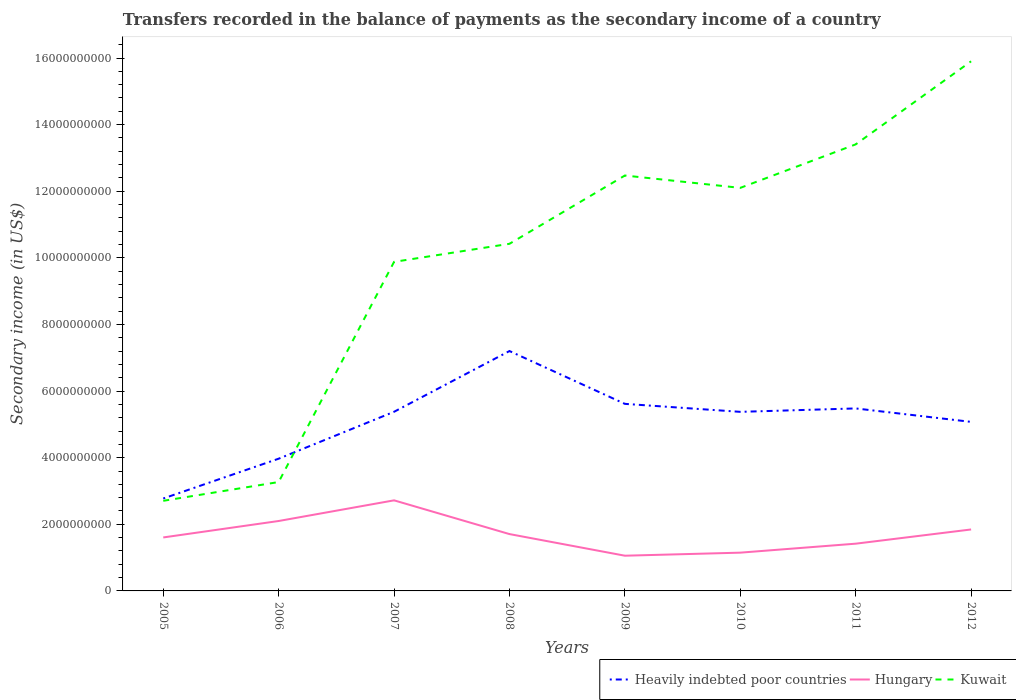Is the number of lines equal to the number of legend labels?
Make the answer very short. Yes. Across all years, what is the maximum secondary income of in Hungary?
Offer a very short reply. 1.06e+09. What is the total secondary income of in Hungary in the graph?
Your answer should be very brief. -1.39e+08. What is the difference between the highest and the second highest secondary income of in Kuwait?
Offer a very short reply. 1.32e+1. Is the secondary income of in Heavily indebted poor countries strictly greater than the secondary income of in Kuwait over the years?
Your response must be concise. No. Does the graph contain any zero values?
Your answer should be compact. No. How many legend labels are there?
Provide a succinct answer. 3. What is the title of the graph?
Your answer should be compact. Transfers recorded in the balance of payments as the secondary income of a country. What is the label or title of the Y-axis?
Give a very brief answer. Secondary income (in US$). What is the Secondary income (in US$) in Heavily indebted poor countries in 2005?
Make the answer very short. 2.77e+09. What is the Secondary income (in US$) of Hungary in 2005?
Make the answer very short. 1.61e+09. What is the Secondary income (in US$) in Kuwait in 2005?
Ensure brevity in your answer.  2.71e+09. What is the Secondary income (in US$) in Heavily indebted poor countries in 2006?
Offer a very short reply. 3.97e+09. What is the Secondary income (in US$) in Hungary in 2006?
Provide a short and direct response. 2.10e+09. What is the Secondary income (in US$) in Kuwait in 2006?
Ensure brevity in your answer.  3.27e+09. What is the Secondary income (in US$) in Heavily indebted poor countries in 2007?
Offer a very short reply. 5.38e+09. What is the Secondary income (in US$) in Hungary in 2007?
Give a very brief answer. 2.72e+09. What is the Secondary income (in US$) in Kuwait in 2007?
Offer a terse response. 9.88e+09. What is the Secondary income (in US$) in Heavily indebted poor countries in 2008?
Provide a succinct answer. 7.20e+09. What is the Secondary income (in US$) of Hungary in 2008?
Keep it short and to the point. 1.71e+09. What is the Secondary income (in US$) of Kuwait in 2008?
Your response must be concise. 1.04e+1. What is the Secondary income (in US$) in Heavily indebted poor countries in 2009?
Ensure brevity in your answer.  5.62e+09. What is the Secondary income (in US$) of Hungary in 2009?
Give a very brief answer. 1.06e+09. What is the Secondary income (in US$) of Kuwait in 2009?
Your response must be concise. 1.25e+1. What is the Secondary income (in US$) of Heavily indebted poor countries in 2010?
Give a very brief answer. 5.38e+09. What is the Secondary income (in US$) in Hungary in 2010?
Give a very brief answer. 1.15e+09. What is the Secondary income (in US$) in Kuwait in 2010?
Provide a short and direct response. 1.21e+1. What is the Secondary income (in US$) in Heavily indebted poor countries in 2011?
Provide a succinct answer. 5.48e+09. What is the Secondary income (in US$) of Hungary in 2011?
Provide a short and direct response. 1.42e+09. What is the Secondary income (in US$) of Kuwait in 2011?
Make the answer very short. 1.34e+1. What is the Secondary income (in US$) of Heavily indebted poor countries in 2012?
Your answer should be compact. 5.08e+09. What is the Secondary income (in US$) in Hungary in 2012?
Keep it short and to the point. 1.85e+09. What is the Secondary income (in US$) of Kuwait in 2012?
Provide a short and direct response. 1.59e+1. Across all years, what is the maximum Secondary income (in US$) of Heavily indebted poor countries?
Your response must be concise. 7.20e+09. Across all years, what is the maximum Secondary income (in US$) of Hungary?
Your response must be concise. 2.72e+09. Across all years, what is the maximum Secondary income (in US$) of Kuwait?
Make the answer very short. 1.59e+1. Across all years, what is the minimum Secondary income (in US$) in Heavily indebted poor countries?
Provide a succinct answer. 2.77e+09. Across all years, what is the minimum Secondary income (in US$) of Hungary?
Your response must be concise. 1.06e+09. Across all years, what is the minimum Secondary income (in US$) in Kuwait?
Provide a short and direct response. 2.71e+09. What is the total Secondary income (in US$) in Heavily indebted poor countries in the graph?
Provide a succinct answer. 4.09e+1. What is the total Secondary income (in US$) in Hungary in the graph?
Provide a succinct answer. 1.36e+1. What is the total Secondary income (in US$) of Kuwait in the graph?
Your response must be concise. 8.02e+1. What is the difference between the Secondary income (in US$) of Heavily indebted poor countries in 2005 and that in 2006?
Make the answer very short. -1.19e+09. What is the difference between the Secondary income (in US$) in Hungary in 2005 and that in 2006?
Your answer should be compact. -4.94e+08. What is the difference between the Secondary income (in US$) in Kuwait in 2005 and that in 2006?
Make the answer very short. -5.64e+08. What is the difference between the Secondary income (in US$) of Heavily indebted poor countries in 2005 and that in 2007?
Keep it short and to the point. -2.60e+09. What is the difference between the Secondary income (in US$) of Hungary in 2005 and that in 2007?
Your answer should be very brief. -1.11e+09. What is the difference between the Secondary income (in US$) of Kuwait in 2005 and that in 2007?
Give a very brief answer. -7.17e+09. What is the difference between the Secondary income (in US$) in Heavily indebted poor countries in 2005 and that in 2008?
Provide a short and direct response. -4.43e+09. What is the difference between the Secondary income (in US$) in Hungary in 2005 and that in 2008?
Ensure brevity in your answer.  -1.01e+08. What is the difference between the Secondary income (in US$) of Kuwait in 2005 and that in 2008?
Offer a very short reply. -7.72e+09. What is the difference between the Secondary income (in US$) in Heavily indebted poor countries in 2005 and that in 2009?
Provide a succinct answer. -2.84e+09. What is the difference between the Secondary income (in US$) in Hungary in 2005 and that in 2009?
Provide a short and direct response. 5.48e+08. What is the difference between the Secondary income (in US$) of Kuwait in 2005 and that in 2009?
Provide a short and direct response. -9.77e+09. What is the difference between the Secondary income (in US$) of Heavily indebted poor countries in 2005 and that in 2010?
Ensure brevity in your answer.  -2.60e+09. What is the difference between the Secondary income (in US$) in Hungary in 2005 and that in 2010?
Your response must be concise. 4.57e+08. What is the difference between the Secondary income (in US$) of Kuwait in 2005 and that in 2010?
Ensure brevity in your answer.  -9.40e+09. What is the difference between the Secondary income (in US$) of Heavily indebted poor countries in 2005 and that in 2011?
Ensure brevity in your answer.  -2.70e+09. What is the difference between the Secondary income (in US$) in Hungary in 2005 and that in 2011?
Your answer should be very brief. 1.87e+08. What is the difference between the Secondary income (in US$) of Kuwait in 2005 and that in 2011?
Your response must be concise. -1.07e+1. What is the difference between the Secondary income (in US$) of Heavily indebted poor countries in 2005 and that in 2012?
Offer a very short reply. -2.30e+09. What is the difference between the Secondary income (in US$) of Hungary in 2005 and that in 2012?
Make the answer very short. -2.40e+08. What is the difference between the Secondary income (in US$) in Kuwait in 2005 and that in 2012?
Offer a very short reply. -1.32e+1. What is the difference between the Secondary income (in US$) of Heavily indebted poor countries in 2006 and that in 2007?
Provide a succinct answer. -1.41e+09. What is the difference between the Secondary income (in US$) of Hungary in 2006 and that in 2007?
Offer a terse response. -6.20e+08. What is the difference between the Secondary income (in US$) in Kuwait in 2006 and that in 2007?
Your answer should be very brief. -6.61e+09. What is the difference between the Secondary income (in US$) of Heavily indebted poor countries in 2006 and that in 2008?
Keep it short and to the point. -3.23e+09. What is the difference between the Secondary income (in US$) of Hungary in 2006 and that in 2008?
Your answer should be very brief. 3.93e+08. What is the difference between the Secondary income (in US$) of Kuwait in 2006 and that in 2008?
Your answer should be compact. -7.15e+09. What is the difference between the Secondary income (in US$) of Heavily indebted poor countries in 2006 and that in 2009?
Offer a terse response. -1.65e+09. What is the difference between the Secondary income (in US$) of Hungary in 2006 and that in 2009?
Give a very brief answer. 1.04e+09. What is the difference between the Secondary income (in US$) of Kuwait in 2006 and that in 2009?
Provide a succinct answer. -9.20e+09. What is the difference between the Secondary income (in US$) of Heavily indebted poor countries in 2006 and that in 2010?
Ensure brevity in your answer.  -1.41e+09. What is the difference between the Secondary income (in US$) in Hungary in 2006 and that in 2010?
Ensure brevity in your answer.  9.50e+08. What is the difference between the Secondary income (in US$) of Kuwait in 2006 and that in 2010?
Give a very brief answer. -8.83e+09. What is the difference between the Secondary income (in US$) in Heavily indebted poor countries in 2006 and that in 2011?
Your response must be concise. -1.51e+09. What is the difference between the Secondary income (in US$) of Hungary in 2006 and that in 2011?
Your response must be concise. 6.81e+08. What is the difference between the Secondary income (in US$) of Kuwait in 2006 and that in 2011?
Keep it short and to the point. -1.01e+1. What is the difference between the Secondary income (in US$) of Heavily indebted poor countries in 2006 and that in 2012?
Provide a succinct answer. -1.11e+09. What is the difference between the Secondary income (in US$) in Hungary in 2006 and that in 2012?
Offer a terse response. 2.54e+08. What is the difference between the Secondary income (in US$) in Kuwait in 2006 and that in 2012?
Keep it short and to the point. -1.26e+1. What is the difference between the Secondary income (in US$) in Heavily indebted poor countries in 2007 and that in 2008?
Provide a succinct answer. -1.82e+09. What is the difference between the Secondary income (in US$) in Hungary in 2007 and that in 2008?
Offer a terse response. 1.01e+09. What is the difference between the Secondary income (in US$) in Kuwait in 2007 and that in 2008?
Keep it short and to the point. -5.42e+08. What is the difference between the Secondary income (in US$) in Heavily indebted poor countries in 2007 and that in 2009?
Your answer should be compact. -2.38e+08. What is the difference between the Secondary income (in US$) of Hungary in 2007 and that in 2009?
Your response must be concise. 1.66e+09. What is the difference between the Secondary income (in US$) in Kuwait in 2007 and that in 2009?
Provide a short and direct response. -2.59e+09. What is the difference between the Secondary income (in US$) of Heavily indebted poor countries in 2007 and that in 2010?
Ensure brevity in your answer.  1.70e+06. What is the difference between the Secondary income (in US$) of Hungary in 2007 and that in 2010?
Offer a terse response. 1.57e+09. What is the difference between the Secondary income (in US$) in Kuwait in 2007 and that in 2010?
Ensure brevity in your answer.  -2.22e+09. What is the difference between the Secondary income (in US$) of Heavily indebted poor countries in 2007 and that in 2011?
Your answer should be compact. -1.01e+08. What is the difference between the Secondary income (in US$) of Hungary in 2007 and that in 2011?
Your answer should be compact. 1.30e+09. What is the difference between the Secondary income (in US$) in Kuwait in 2007 and that in 2011?
Your answer should be compact. -3.53e+09. What is the difference between the Secondary income (in US$) of Heavily indebted poor countries in 2007 and that in 2012?
Ensure brevity in your answer.  3.03e+08. What is the difference between the Secondary income (in US$) in Hungary in 2007 and that in 2012?
Your response must be concise. 8.74e+08. What is the difference between the Secondary income (in US$) of Kuwait in 2007 and that in 2012?
Keep it short and to the point. -6.02e+09. What is the difference between the Secondary income (in US$) of Heavily indebted poor countries in 2008 and that in 2009?
Your response must be concise. 1.59e+09. What is the difference between the Secondary income (in US$) of Hungary in 2008 and that in 2009?
Give a very brief answer. 6.49e+08. What is the difference between the Secondary income (in US$) of Kuwait in 2008 and that in 2009?
Ensure brevity in your answer.  -2.05e+09. What is the difference between the Secondary income (in US$) in Heavily indebted poor countries in 2008 and that in 2010?
Give a very brief answer. 1.83e+09. What is the difference between the Secondary income (in US$) in Hungary in 2008 and that in 2010?
Ensure brevity in your answer.  5.58e+08. What is the difference between the Secondary income (in US$) of Kuwait in 2008 and that in 2010?
Offer a very short reply. -1.68e+09. What is the difference between the Secondary income (in US$) of Heavily indebted poor countries in 2008 and that in 2011?
Provide a short and direct response. 1.72e+09. What is the difference between the Secondary income (in US$) of Hungary in 2008 and that in 2011?
Offer a terse response. 2.88e+08. What is the difference between the Secondary income (in US$) of Kuwait in 2008 and that in 2011?
Keep it short and to the point. -2.99e+09. What is the difference between the Secondary income (in US$) of Heavily indebted poor countries in 2008 and that in 2012?
Ensure brevity in your answer.  2.13e+09. What is the difference between the Secondary income (in US$) in Hungary in 2008 and that in 2012?
Offer a very short reply. -1.39e+08. What is the difference between the Secondary income (in US$) of Kuwait in 2008 and that in 2012?
Give a very brief answer. -5.48e+09. What is the difference between the Secondary income (in US$) of Heavily indebted poor countries in 2009 and that in 2010?
Your response must be concise. 2.40e+08. What is the difference between the Secondary income (in US$) of Hungary in 2009 and that in 2010?
Your response must be concise. -9.17e+07. What is the difference between the Secondary income (in US$) in Kuwait in 2009 and that in 2010?
Your answer should be very brief. 3.71e+08. What is the difference between the Secondary income (in US$) of Heavily indebted poor countries in 2009 and that in 2011?
Give a very brief answer. 1.37e+08. What is the difference between the Secondary income (in US$) in Hungary in 2009 and that in 2011?
Provide a short and direct response. -3.61e+08. What is the difference between the Secondary income (in US$) of Kuwait in 2009 and that in 2011?
Keep it short and to the point. -9.35e+08. What is the difference between the Secondary income (in US$) of Heavily indebted poor countries in 2009 and that in 2012?
Ensure brevity in your answer.  5.41e+08. What is the difference between the Secondary income (in US$) of Hungary in 2009 and that in 2012?
Provide a succinct answer. -7.88e+08. What is the difference between the Secondary income (in US$) of Kuwait in 2009 and that in 2012?
Give a very brief answer. -3.43e+09. What is the difference between the Secondary income (in US$) of Heavily indebted poor countries in 2010 and that in 2011?
Your answer should be very brief. -1.03e+08. What is the difference between the Secondary income (in US$) in Hungary in 2010 and that in 2011?
Ensure brevity in your answer.  -2.70e+08. What is the difference between the Secondary income (in US$) of Kuwait in 2010 and that in 2011?
Offer a terse response. -1.31e+09. What is the difference between the Secondary income (in US$) of Heavily indebted poor countries in 2010 and that in 2012?
Provide a short and direct response. 3.01e+08. What is the difference between the Secondary income (in US$) in Hungary in 2010 and that in 2012?
Provide a short and direct response. -6.96e+08. What is the difference between the Secondary income (in US$) of Kuwait in 2010 and that in 2012?
Your response must be concise. -3.80e+09. What is the difference between the Secondary income (in US$) in Heavily indebted poor countries in 2011 and that in 2012?
Provide a succinct answer. 4.04e+08. What is the difference between the Secondary income (in US$) of Hungary in 2011 and that in 2012?
Provide a short and direct response. -4.27e+08. What is the difference between the Secondary income (in US$) of Kuwait in 2011 and that in 2012?
Provide a short and direct response. -2.49e+09. What is the difference between the Secondary income (in US$) of Heavily indebted poor countries in 2005 and the Secondary income (in US$) of Hungary in 2006?
Keep it short and to the point. 6.76e+08. What is the difference between the Secondary income (in US$) of Heavily indebted poor countries in 2005 and the Secondary income (in US$) of Kuwait in 2006?
Your response must be concise. -4.94e+08. What is the difference between the Secondary income (in US$) in Hungary in 2005 and the Secondary income (in US$) in Kuwait in 2006?
Your answer should be compact. -1.66e+09. What is the difference between the Secondary income (in US$) of Heavily indebted poor countries in 2005 and the Secondary income (in US$) of Hungary in 2007?
Offer a terse response. 5.52e+07. What is the difference between the Secondary income (in US$) in Heavily indebted poor countries in 2005 and the Secondary income (in US$) in Kuwait in 2007?
Provide a short and direct response. -7.10e+09. What is the difference between the Secondary income (in US$) in Hungary in 2005 and the Secondary income (in US$) in Kuwait in 2007?
Your answer should be very brief. -8.27e+09. What is the difference between the Secondary income (in US$) in Heavily indebted poor countries in 2005 and the Secondary income (in US$) in Hungary in 2008?
Ensure brevity in your answer.  1.07e+09. What is the difference between the Secondary income (in US$) in Heavily indebted poor countries in 2005 and the Secondary income (in US$) in Kuwait in 2008?
Your response must be concise. -7.65e+09. What is the difference between the Secondary income (in US$) in Hungary in 2005 and the Secondary income (in US$) in Kuwait in 2008?
Offer a terse response. -8.82e+09. What is the difference between the Secondary income (in US$) of Heavily indebted poor countries in 2005 and the Secondary income (in US$) of Hungary in 2009?
Provide a short and direct response. 1.72e+09. What is the difference between the Secondary income (in US$) in Heavily indebted poor countries in 2005 and the Secondary income (in US$) in Kuwait in 2009?
Keep it short and to the point. -9.70e+09. What is the difference between the Secondary income (in US$) in Hungary in 2005 and the Secondary income (in US$) in Kuwait in 2009?
Make the answer very short. -1.09e+1. What is the difference between the Secondary income (in US$) in Heavily indebted poor countries in 2005 and the Secondary income (in US$) in Hungary in 2010?
Give a very brief answer. 1.63e+09. What is the difference between the Secondary income (in US$) of Heavily indebted poor countries in 2005 and the Secondary income (in US$) of Kuwait in 2010?
Your answer should be compact. -9.33e+09. What is the difference between the Secondary income (in US$) of Hungary in 2005 and the Secondary income (in US$) of Kuwait in 2010?
Your answer should be compact. -1.05e+1. What is the difference between the Secondary income (in US$) of Heavily indebted poor countries in 2005 and the Secondary income (in US$) of Hungary in 2011?
Your answer should be very brief. 1.36e+09. What is the difference between the Secondary income (in US$) of Heavily indebted poor countries in 2005 and the Secondary income (in US$) of Kuwait in 2011?
Offer a terse response. -1.06e+1. What is the difference between the Secondary income (in US$) of Hungary in 2005 and the Secondary income (in US$) of Kuwait in 2011?
Provide a short and direct response. -1.18e+1. What is the difference between the Secondary income (in US$) in Heavily indebted poor countries in 2005 and the Secondary income (in US$) in Hungary in 2012?
Keep it short and to the point. 9.30e+08. What is the difference between the Secondary income (in US$) in Heavily indebted poor countries in 2005 and the Secondary income (in US$) in Kuwait in 2012?
Give a very brief answer. -1.31e+1. What is the difference between the Secondary income (in US$) of Hungary in 2005 and the Secondary income (in US$) of Kuwait in 2012?
Ensure brevity in your answer.  -1.43e+1. What is the difference between the Secondary income (in US$) of Heavily indebted poor countries in 2006 and the Secondary income (in US$) of Hungary in 2007?
Provide a short and direct response. 1.25e+09. What is the difference between the Secondary income (in US$) in Heavily indebted poor countries in 2006 and the Secondary income (in US$) in Kuwait in 2007?
Keep it short and to the point. -5.91e+09. What is the difference between the Secondary income (in US$) of Hungary in 2006 and the Secondary income (in US$) of Kuwait in 2007?
Make the answer very short. -7.78e+09. What is the difference between the Secondary income (in US$) of Heavily indebted poor countries in 2006 and the Secondary income (in US$) of Hungary in 2008?
Your response must be concise. 2.26e+09. What is the difference between the Secondary income (in US$) of Heavily indebted poor countries in 2006 and the Secondary income (in US$) of Kuwait in 2008?
Your answer should be very brief. -6.45e+09. What is the difference between the Secondary income (in US$) of Hungary in 2006 and the Secondary income (in US$) of Kuwait in 2008?
Keep it short and to the point. -8.32e+09. What is the difference between the Secondary income (in US$) in Heavily indebted poor countries in 2006 and the Secondary income (in US$) in Hungary in 2009?
Your response must be concise. 2.91e+09. What is the difference between the Secondary income (in US$) in Heavily indebted poor countries in 2006 and the Secondary income (in US$) in Kuwait in 2009?
Your answer should be very brief. -8.50e+09. What is the difference between the Secondary income (in US$) in Hungary in 2006 and the Secondary income (in US$) in Kuwait in 2009?
Ensure brevity in your answer.  -1.04e+1. What is the difference between the Secondary income (in US$) of Heavily indebted poor countries in 2006 and the Secondary income (in US$) of Hungary in 2010?
Offer a terse response. 2.82e+09. What is the difference between the Secondary income (in US$) in Heavily indebted poor countries in 2006 and the Secondary income (in US$) in Kuwait in 2010?
Provide a short and direct response. -8.13e+09. What is the difference between the Secondary income (in US$) of Hungary in 2006 and the Secondary income (in US$) of Kuwait in 2010?
Provide a short and direct response. -1.00e+1. What is the difference between the Secondary income (in US$) in Heavily indebted poor countries in 2006 and the Secondary income (in US$) in Hungary in 2011?
Provide a short and direct response. 2.55e+09. What is the difference between the Secondary income (in US$) of Heavily indebted poor countries in 2006 and the Secondary income (in US$) of Kuwait in 2011?
Give a very brief answer. -9.44e+09. What is the difference between the Secondary income (in US$) in Hungary in 2006 and the Secondary income (in US$) in Kuwait in 2011?
Your answer should be compact. -1.13e+1. What is the difference between the Secondary income (in US$) of Heavily indebted poor countries in 2006 and the Secondary income (in US$) of Hungary in 2012?
Offer a very short reply. 2.12e+09. What is the difference between the Secondary income (in US$) in Heavily indebted poor countries in 2006 and the Secondary income (in US$) in Kuwait in 2012?
Ensure brevity in your answer.  -1.19e+1. What is the difference between the Secondary income (in US$) in Hungary in 2006 and the Secondary income (in US$) in Kuwait in 2012?
Provide a succinct answer. -1.38e+1. What is the difference between the Secondary income (in US$) of Heavily indebted poor countries in 2007 and the Secondary income (in US$) of Hungary in 2008?
Offer a terse response. 3.67e+09. What is the difference between the Secondary income (in US$) of Heavily indebted poor countries in 2007 and the Secondary income (in US$) of Kuwait in 2008?
Give a very brief answer. -5.04e+09. What is the difference between the Secondary income (in US$) in Hungary in 2007 and the Secondary income (in US$) in Kuwait in 2008?
Keep it short and to the point. -7.70e+09. What is the difference between the Secondary income (in US$) of Heavily indebted poor countries in 2007 and the Secondary income (in US$) of Hungary in 2009?
Offer a terse response. 4.32e+09. What is the difference between the Secondary income (in US$) of Heavily indebted poor countries in 2007 and the Secondary income (in US$) of Kuwait in 2009?
Your answer should be compact. -7.09e+09. What is the difference between the Secondary income (in US$) in Hungary in 2007 and the Secondary income (in US$) in Kuwait in 2009?
Your answer should be very brief. -9.75e+09. What is the difference between the Secondary income (in US$) of Heavily indebted poor countries in 2007 and the Secondary income (in US$) of Hungary in 2010?
Give a very brief answer. 4.23e+09. What is the difference between the Secondary income (in US$) of Heavily indebted poor countries in 2007 and the Secondary income (in US$) of Kuwait in 2010?
Ensure brevity in your answer.  -6.72e+09. What is the difference between the Secondary income (in US$) of Hungary in 2007 and the Secondary income (in US$) of Kuwait in 2010?
Make the answer very short. -9.38e+09. What is the difference between the Secondary income (in US$) in Heavily indebted poor countries in 2007 and the Secondary income (in US$) in Hungary in 2011?
Offer a terse response. 3.96e+09. What is the difference between the Secondary income (in US$) of Heavily indebted poor countries in 2007 and the Secondary income (in US$) of Kuwait in 2011?
Give a very brief answer. -8.03e+09. What is the difference between the Secondary income (in US$) in Hungary in 2007 and the Secondary income (in US$) in Kuwait in 2011?
Offer a very short reply. -1.07e+1. What is the difference between the Secondary income (in US$) of Heavily indebted poor countries in 2007 and the Secondary income (in US$) of Hungary in 2012?
Your answer should be compact. 3.53e+09. What is the difference between the Secondary income (in US$) in Heavily indebted poor countries in 2007 and the Secondary income (in US$) in Kuwait in 2012?
Give a very brief answer. -1.05e+1. What is the difference between the Secondary income (in US$) of Hungary in 2007 and the Secondary income (in US$) of Kuwait in 2012?
Keep it short and to the point. -1.32e+1. What is the difference between the Secondary income (in US$) in Heavily indebted poor countries in 2008 and the Secondary income (in US$) in Hungary in 2009?
Offer a very short reply. 6.15e+09. What is the difference between the Secondary income (in US$) of Heavily indebted poor countries in 2008 and the Secondary income (in US$) of Kuwait in 2009?
Give a very brief answer. -5.27e+09. What is the difference between the Secondary income (in US$) in Hungary in 2008 and the Secondary income (in US$) in Kuwait in 2009?
Provide a succinct answer. -1.08e+1. What is the difference between the Secondary income (in US$) of Heavily indebted poor countries in 2008 and the Secondary income (in US$) of Hungary in 2010?
Provide a short and direct response. 6.05e+09. What is the difference between the Secondary income (in US$) in Heavily indebted poor countries in 2008 and the Secondary income (in US$) in Kuwait in 2010?
Provide a succinct answer. -4.90e+09. What is the difference between the Secondary income (in US$) in Hungary in 2008 and the Secondary income (in US$) in Kuwait in 2010?
Offer a terse response. -1.04e+1. What is the difference between the Secondary income (in US$) in Heavily indebted poor countries in 2008 and the Secondary income (in US$) in Hungary in 2011?
Ensure brevity in your answer.  5.78e+09. What is the difference between the Secondary income (in US$) in Heavily indebted poor countries in 2008 and the Secondary income (in US$) in Kuwait in 2011?
Provide a succinct answer. -6.21e+09. What is the difference between the Secondary income (in US$) of Hungary in 2008 and the Secondary income (in US$) of Kuwait in 2011?
Your answer should be compact. -1.17e+1. What is the difference between the Secondary income (in US$) in Heavily indebted poor countries in 2008 and the Secondary income (in US$) in Hungary in 2012?
Make the answer very short. 5.36e+09. What is the difference between the Secondary income (in US$) of Heavily indebted poor countries in 2008 and the Secondary income (in US$) of Kuwait in 2012?
Your response must be concise. -8.70e+09. What is the difference between the Secondary income (in US$) of Hungary in 2008 and the Secondary income (in US$) of Kuwait in 2012?
Make the answer very short. -1.42e+1. What is the difference between the Secondary income (in US$) in Heavily indebted poor countries in 2009 and the Secondary income (in US$) in Hungary in 2010?
Your answer should be compact. 4.47e+09. What is the difference between the Secondary income (in US$) in Heavily indebted poor countries in 2009 and the Secondary income (in US$) in Kuwait in 2010?
Ensure brevity in your answer.  -6.48e+09. What is the difference between the Secondary income (in US$) in Hungary in 2009 and the Secondary income (in US$) in Kuwait in 2010?
Provide a succinct answer. -1.10e+1. What is the difference between the Secondary income (in US$) of Heavily indebted poor countries in 2009 and the Secondary income (in US$) of Hungary in 2011?
Provide a short and direct response. 4.20e+09. What is the difference between the Secondary income (in US$) in Heavily indebted poor countries in 2009 and the Secondary income (in US$) in Kuwait in 2011?
Provide a succinct answer. -7.79e+09. What is the difference between the Secondary income (in US$) in Hungary in 2009 and the Secondary income (in US$) in Kuwait in 2011?
Provide a succinct answer. -1.24e+1. What is the difference between the Secondary income (in US$) of Heavily indebted poor countries in 2009 and the Secondary income (in US$) of Hungary in 2012?
Your answer should be very brief. 3.77e+09. What is the difference between the Secondary income (in US$) of Heavily indebted poor countries in 2009 and the Secondary income (in US$) of Kuwait in 2012?
Offer a very short reply. -1.03e+1. What is the difference between the Secondary income (in US$) in Hungary in 2009 and the Secondary income (in US$) in Kuwait in 2012?
Offer a very short reply. -1.48e+1. What is the difference between the Secondary income (in US$) in Heavily indebted poor countries in 2010 and the Secondary income (in US$) in Hungary in 2011?
Offer a terse response. 3.96e+09. What is the difference between the Secondary income (in US$) in Heavily indebted poor countries in 2010 and the Secondary income (in US$) in Kuwait in 2011?
Offer a very short reply. -8.03e+09. What is the difference between the Secondary income (in US$) in Hungary in 2010 and the Secondary income (in US$) in Kuwait in 2011?
Ensure brevity in your answer.  -1.23e+1. What is the difference between the Secondary income (in US$) of Heavily indebted poor countries in 2010 and the Secondary income (in US$) of Hungary in 2012?
Your answer should be very brief. 3.53e+09. What is the difference between the Secondary income (in US$) of Heavily indebted poor countries in 2010 and the Secondary income (in US$) of Kuwait in 2012?
Keep it short and to the point. -1.05e+1. What is the difference between the Secondary income (in US$) of Hungary in 2010 and the Secondary income (in US$) of Kuwait in 2012?
Offer a terse response. -1.48e+1. What is the difference between the Secondary income (in US$) in Heavily indebted poor countries in 2011 and the Secondary income (in US$) in Hungary in 2012?
Offer a very short reply. 3.63e+09. What is the difference between the Secondary income (in US$) in Heavily indebted poor countries in 2011 and the Secondary income (in US$) in Kuwait in 2012?
Provide a short and direct response. -1.04e+1. What is the difference between the Secondary income (in US$) in Hungary in 2011 and the Secondary income (in US$) in Kuwait in 2012?
Your answer should be compact. -1.45e+1. What is the average Secondary income (in US$) in Heavily indebted poor countries per year?
Provide a short and direct response. 5.11e+09. What is the average Secondary income (in US$) of Hungary per year?
Offer a very short reply. 1.70e+09. What is the average Secondary income (in US$) in Kuwait per year?
Ensure brevity in your answer.  1.00e+1. In the year 2005, what is the difference between the Secondary income (in US$) of Heavily indebted poor countries and Secondary income (in US$) of Hungary?
Keep it short and to the point. 1.17e+09. In the year 2005, what is the difference between the Secondary income (in US$) in Heavily indebted poor countries and Secondary income (in US$) in Kuwait?
Make the answer very short. 6.95e+07. In the year 2005, what is the difference between the Secondary income (in US$) in Hungary and Secondary income (in US$) in Kuwait?
Provide a succinct answer. -1.10e+09. In the year 2006, what is the difference between the Secondary income (in US$) in Heavily indebted poor countries and Secondary income (in US$) in Hungary?
Your answer should be compact. 1.87e+09. In the year 2006, what is the difference between the Secondary income (in US$) of Heavily indebted poor countries and Secondary income (in US$) of Kuwait?
Your answer should be compact. 7.01e+08. In the year 2006, what is the difference between the Secondary income (in US$) of Hungary and Secondary income (in US$) of Kuwait?
Provide a succinct answer. -1.17e+09. In the year 2007, what is the difference between the Secondary income (in US$) of Heavily indebted poor countries and Secondary income (in US$) of Hungary?
Make the answer very short. 2.66e+09. In the year 2007, what is the difference between the Secondary income (in US$) in Heavily indebted poor countries and Secondary income (in US$) in Kuwait?
Keep it short and to the point. -4.50e+09. In the year 2007, what is the difference between the Secondary income (in US$) in Hungary and Secondary income (in US$) in Kuwait?
Offer a very short reply. -7.16e+09. In the year 2008, what is the difference between the Secondary income (in US$) in Heavily indebted poor countries and Secondary income (in US$) in Hungary?
Keep it short and to the point. 5.50e+09. In the year 2008, what is the difference between the Secondary income (in US$) in Heavily indebted poor countries and Secondary income (in US$) in Kuwait?
Your answer should be compact. -3.22e+09. In the year 2008, what is the difference between the Secondary income (in US$) in Hungary and Secondary income (in US$) in Kuwait?
Provide a succinct answer. -8.72e+09. In the year 2009, what is the difference between the Secondary income (in US$) in Heavily indebted poor countries and Secondary income (in US$) in Hungary?
Offer a terse response. 4.56e+09. In the year 2009, what is the difference between the Secondary income (in US$) of Heavily indebted poor countries and Secondary income (in US$) of Kuwait?
Keep it short and to the point. -6.86e+09. In the year 2009, what is the difference between the Secondary income (in US$) in Hungary and Secondary income (in US$) in Kuwait?
Provide a succinct answer. -1.14e+1. In the year 2010, what is the difference between the Secondary income (in US$) of Heavily indebted poor countries and Secondary income (in US$) of Hungary?
Give a very brief answer. 4.23e+09. In the year 2010, what is the difference between the Secondary income (in US$) in Heavily indebted poor countries and Secondary income (in US$) in Kuwait?
Provide a short and direct response. -6.72e+09. In the year 2010, what is the difference between the Secondary income (in US$) in Hungary and Secondary income (in US$) in Kuwait?
Offer a very short reply. -1.10e+1. In the year 2011, what is the difference between the Secondary income (in US$) in Heavily indebted poor countries and Secondary income (in US$) in Hungary?
Provide a succinct answer. 4.06e+09. In the year 2011, what is the difference between the Secondary income (in US$) of Heavily indebted poor countries and Secondary income (in US$) of Kuwait?
Your answer should be very brief. -7.93e+09. In the year 2011, what is the difference between the Secondary income (in US$) of Hungary and Secondary income (in US$) of Kuwait?
Make the answer very short. -1.20e+1. In the year 2012, what is the difference between the Secondary income (in US$) in Heavily indebted poor countries and Secondary income (in US$) in Hungary?
Provide a succinct answer. 3.23e+09. In the year 2012, what is the difference between the Secondary income (in US$) of Heavily indebted poor countries and Secondary income (in US$) of Kuwait?
Your response must be concise. -1.08e+1. In the year 2012, what is the difference between the Secondary income (in US$) of Hungary and Secondary income (in US$) of Kuwait?
Ensure brevity in your answer.  -1.41e+1. What is the ratio of the Secondary income (in US$) in Heavily indebted poor countries in 2005 to that in 2006?
Provide a short and direct response. 0.7. What is the ratio of the Secondary income (in US$) of Hungary in 2005 to that in 2006?
Make the answer very short. 0.76. What is the ratio of the Secondary income (in US$) of Kuwait in 2005 to that in 2006?
Keep it short and to the point. 0.83. What is the ratio of the Secondary income (in US$) in Heavily indebted poor countries in 2005 to that in 2007?
Offer a terse response. 0.52. What is the ratio of the Secondary income (in US$) of Hungary in 2005 to that in 2007?
Provide a succinct answer. 0.59. What is the ratio of the Secondary income (in US$) in Kuwait in 2005 to that in 2007?
Provide a short and direct response. 0.27. What is the ratio of the Secondary income (in US$) in Heavily indebted poor countries in 2005 to that in 2008?
Give a very brief answer. 0.39. What is the ratio of the Secondary income (in US$) in Hungary in 2005 to that in 2008?
Your answer should be very brief. 0.94. What is the ratio of the Secondary income (in US$) of Kuwait in 2005 to that in 2008?
Give a very brief answer. 0.26. What is the ratio of the Secondary income (in US$) in Heavily indebted poor countries in 2005 to that in 2009?
Provide a short and direct response. 0.49. What is the ratio of the Secondary income (in US$) in Hungary in 2005 to that in 2009?
Ensure brevity in your answer.  1.52. What is the ratio of the Secondary income (in US$) of Kuwait in 2005 to that in 2009?
Your answer should be compact. 0.22. What is the ratio of the Secondary income (in US$) in Heavily indebted poor countries in 2005 to that in 2010?
Provide a short and direct response. 0.52. What is the ratio of the Secondary income (in US$) in Hungary in 2005 to that in 2010?
Your response must be concise. 1.4. What is the ratio of the Secondary income (in US$) of Kuwait in 2005 to that in 2010?
Offer a very short reply. 0.22. What is the ratio of the Secondary income (in US$) in Heavily indebted poor countries in 2005 to that in 2011?
Offer a very short reply. 0.51. What is the ratio of the Secondary income (in US$) in Hungary in 2005 to that in 2011?
Offer a very short reply. 1.13. What is the ratio of the Secondary income (in US$) in Kuwait in 2005 to that in 2011?
Offer a very short reply. 0.2. What is the ratio of the Secondary income (in US$) in Heavily indebted poor countries in 2005 to that in 2012?
Offer a terse response. 0.55. What is the ratio of the Secondary income (in US$) of Hungary in 2005 to that in 2012?
Offer a very short reply. 0.87. What is the ratio of the Secondary income (in US$) in Kuwait in 2005 to that in 2012?
Keep it short and to the point. 0.17. What is the ratio of the Secondary income (in US$) of Heavily indebted poor countries in 2006 to that in 2007?
Your answer should be very brief. 0.74. What is the ratio of the Secondary income (in US$) in Hungary in 2006 to that in 2007?
Provide a succinct answer. 0.77. What is the ratio of the Secondary income (in US$) in Kuwait in 2006 to that in 2007?
Your response must be concise. 0.33. What is the ratio of the Secondary income (in US$) in Heavily indebted poor countries in 2006 to that in 2008?
Keep it short and to the point. 0.55. What is the ratio of the Secondary income (in US$) in Hungary in 2006 to that in 2008?
Provide a succinct answer. 1.23. What is the ratio of the Secondary income (in US$) of Kuwait in 2006 to that in 2008?
Your response must be concise. 0.31. What is the ratio of the Secondary income (in US$) in Heavily indebted poor countries in 2006 to that in 2009?
Keep it short and to the point. 0.71. What is the ratio of the Secondary income (in US$) in Hungary in 2006 to that in 2009?
Keep it short and to the point. 1.99. What is the ratio of the Secondary income (in US$) in Kuwait in 2006 to that in 2009?
Your answer should be compact. 0.26. What is the ratio of the Secondary income (in US$) of Heavily indebted poor countries in 2006 to that in 2010?
Your answer should be very brief. 0.74. What is the ratio of the Secondary income (in US$) in Hungary in 2006 to that in 2010?
Offer a terse response. 1.83. What is the ratio of the Secondary income (in US$) in Kuwait in 2006 to that in 2010?
Ensure brevity in your answer.  0.27. What is the ratio of the Secondary income (in US$) of Heavily indebted poor countries in 2006 to that in 2011?
Provide a short and direct response. 0.72. What is the ratio of the Secondary income (in US$) of Hungary in 2006 to that in 2011?
Ensure brevity in your answer.  1.48. What is the ratio of the Secondary income (in US$) in Kuwait in 2006 to that in 2011?
Your answer should be very brief. 0.24. What is the ratio of the Secondary income (in US$) of Heavily indebted poor countries in 2006 to that in 2012?
Provide a succinct answer. 0.78. What is the ratio of the Secondary income (in US$) of Hungary in 2006 to that in 2012?
Ensure brevity in your answer.  1.14. What is the ratio of the Secondary income (in US$) in Kuwait in 2006 to that in 2012?
Give a very brief answer. 0.21. What is the ratio of the Secondary income (in US$) of Heavily indebted poor countries in 2007 to that in 2008?
Your response must be concise. 0.75. What is the ratio of the Secondary income (in US$) of Hungary in 2007 to that in 2008?
Offer a very short reply. 1.59. What is the ratio of the Secondary income (in US$) of Kuwait in 2007 to that in 2008?
Your answer should be very brief. 0.95. What is the ratio of the Secondary income (in US$) in Heavily indebted poor countries in 2007 to that in 2009?
Offer a terse response. 0.96. What is the ratio of the Secondary income (in US$) in Hungary in 2007 to that in 2009?
Offer a very short reply. 2.57. What is the ratio of the Secondary income (in US$) in Kuwait in 2007 to that in 2009?
Your answer should be compact. 0.79. What is the ratio of the Secondary income (in US$) of Hungary in 2007 to that in 2010?
Your response must be concise. 2.37. What is the ratio of the Secondary income (in US$) of Kuwait in 2007 to that in 2010?
Offer a very short reply. 0.82. What is the ratio of the Secondary income (in US$) of Heavily indebted poor countries in 2007 to that in 2011?
Your response must be concise. 0.98. What is the ratio of the Secondary income (in US$) of Hungary in 2007 to that in 2011?
Ensure brevity in your answer.  1.92. What is the ratio of the Secondary income (in US$) in Kuwait in 2007 to that in 2011?
Your answer should be very brief. 0.74. What is the ratio of the Secondary income (in US$) in Heavily indebted poor countries in 2007 to that in 2012?
Provide a short and direct response. 1.06. What is the ratio of the Secondary income (in US$) of Hungary in 2007 to that in 2012?
Make the answer very short. 1.47. What is the ratio of the Secondary income (in US$) of Kuwait in 2007 to that in 2012?
Your response must be concise. 0.62. What is the ratio of the Secondary income (in US$) of Heavily indebted poor countries in 2008 to that in 2009?
Provide a short and direct response. 1.28. What is the ratio of the Secondary income (in US$) of Hungary in 2008 to that in 2009?
Make the answer very short. 1.61. What is the ratio of the Secondary income (in US$) of Kuwait in 2008 to that in 2009?
Make the answer very short. 0.84. What is the ratio of the Secondary income (in US$) in Heavily indebted poor countries in 2008 to that in 2010?
Ensure brevity in your answer.  1.34. What is the ratio of the Secondary income (in US$) of Hungary in 2008 to that in 2010?
Your response must be concise. 1.49. What is the ratio of the Secondary income (in US$) of Kuwait in 2008 to that in 2010?
Your response must be concise. 0.86. What is the ratio of the Secondary income (in US$) in Heavily indebted poor countries in 2008 to that in 2011?
Provide a succinct answer. 1.31. What is the ratio of the Secondary income (in US$) of Hungary in 2008 to that in 2011?
Give a very brief answer. 1.2. What is the ratio of the Secondary income (in US$) of Kuwait in 2008 to that in 2011?
Provide a succinct answer. 0.78. What is the ratio of the Secondary income (in US$) in Heavily indebted poor countries in 2008 to that in 2012?
Provide a succinct answer. 1.42. What is the ratio of the Secondary income (in US$) in Hungary in 2008 to that in 2012?
Provide a short and direct response. 0.92. What is the ratio of the Secondary income (in US$) in Kuwait in 2008 to that in 2012?
Make the answer very short. 0.66. What is the ratio of the Secondary income (in US$) in Heavily indebted poor countries in 2009 to that in 2010?
Offer a very short reply. 1.04. What is the ratio of the Secondary income (in US$) of Hungary in 2009 to that in 2010?
Provide a succinct answer. 0.92. What is the ratio of the Secondary income (in US$) of Kuwait in 2009 to that in 2010?
Your response must be concise. 1.03. What is the ratio of the Secondary income (in US$) in Heavily indebted poor countries in 2009 to that in 2011?
Provide a short and direct response. 1.02. What is the ratio of the Secondary income (in US$) in Hungary in 2009 to that in 2011?
Provide a short and direct response. 0.75. What is the ratio of the Secondary income (in US$) of Kuwait in 2009 to that in 2011?
Provide a succinct answer. 0.93. What is the ratio of the Secondary income (in US$) of Heavily indebted poor countries in 2009 to that in 2012?
Ensure brevity in your answer.  1.11. What is the ratio of the Secondary income (in US$) in Hungary in 2009 to that in 2012?
Offer a terse response. 0.57. What is the ratio of the Secondary income (in US$) of Kuwait in 2009 to that in 2012?
Ensure brevity in your answer.  0.78. What is the ratio of the Secondary income (in US$) in Heavily indebted poor countries in 2010 to that in 2011?
Make the answer very short. 0.98. What is the ratio of the Secondary income (in US$) of Hungary in 2010 to that in 2011?
Provide a short and direct response. 0.81. What is the ratio of the Secondary income (in US$) of Kuwait in 2010 to that in 2011?
Give a very brief answer. 0.9. What is the ratio of the Secondary income (in US$) of Heavily indebted poor countries in 2010 to that in 2012?
Keep it short and to the point. 1.06. What is the ratio of the Secondary income (in US$) of Hungary in 2010 to that in 2012?
Make the answer very short. 0.62. What is the ratio of the Secondary income (in US$) of Kuwait in 2010 to that in 2012?
Your answer should be compact. 0.76. What is the ratio of the Secondary income (in US$) of Heavily indebted poor countries in 2011 to that in 2012?
Your answer should be compact. 1.08. What is the ratio of the Secondary income (in US$) of Hungary in 2011 to that in 2012?
Your response must be concise. 0.77. What is the ratio of the Secondary income (in US$) of Kuwait in 2011 to that in 2012?
Provide a succinct answer. 0.84. What is the difference between the highest and the second highest Secondary income (in US$) of Heavily indebted poor countries?
Your answer should be compact. 1.59e+09. What is the difference between the highest and the second highest Secondary income (in US$) in Hungary?
Ensure brevity in your answer.  6.20e+08. What is the difference between the highest and the second highest Secondary income (in US$) in Kuwait?
Your response must be concise. 2.49e+09. What is the difference between the highest and the lowest Secondary income (in US$) in Heavily indebted poor countries?
Provide a succinct answer. 4.43e+09. What is the difference between the highest and the lowest Secondary income (in US$) of Hungary?
Provide a succinct answer. 1.66e+09. What is the difference between the highest and the lowest Secondary income (in US$) of Kuwait?
Keep it short and to the point. 1.32e+1. 